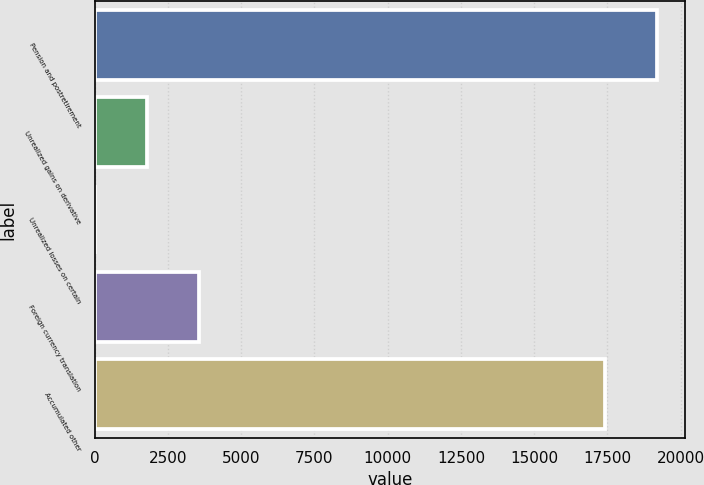Convert chart to OTSL. <chart><loc_0><loc_0><loc_500><loc_500><bar_chart><fcel>Pension and postretirement<fcel>Unrealized gains on derivative<fcel>Unrealized losses on certain<fcel>Foreign currency translation<fcel>Accumulated other<nl><fcel>19186<fcel>1778<fcel>8<fcel>3548<fcel>17416<nl></chart> 